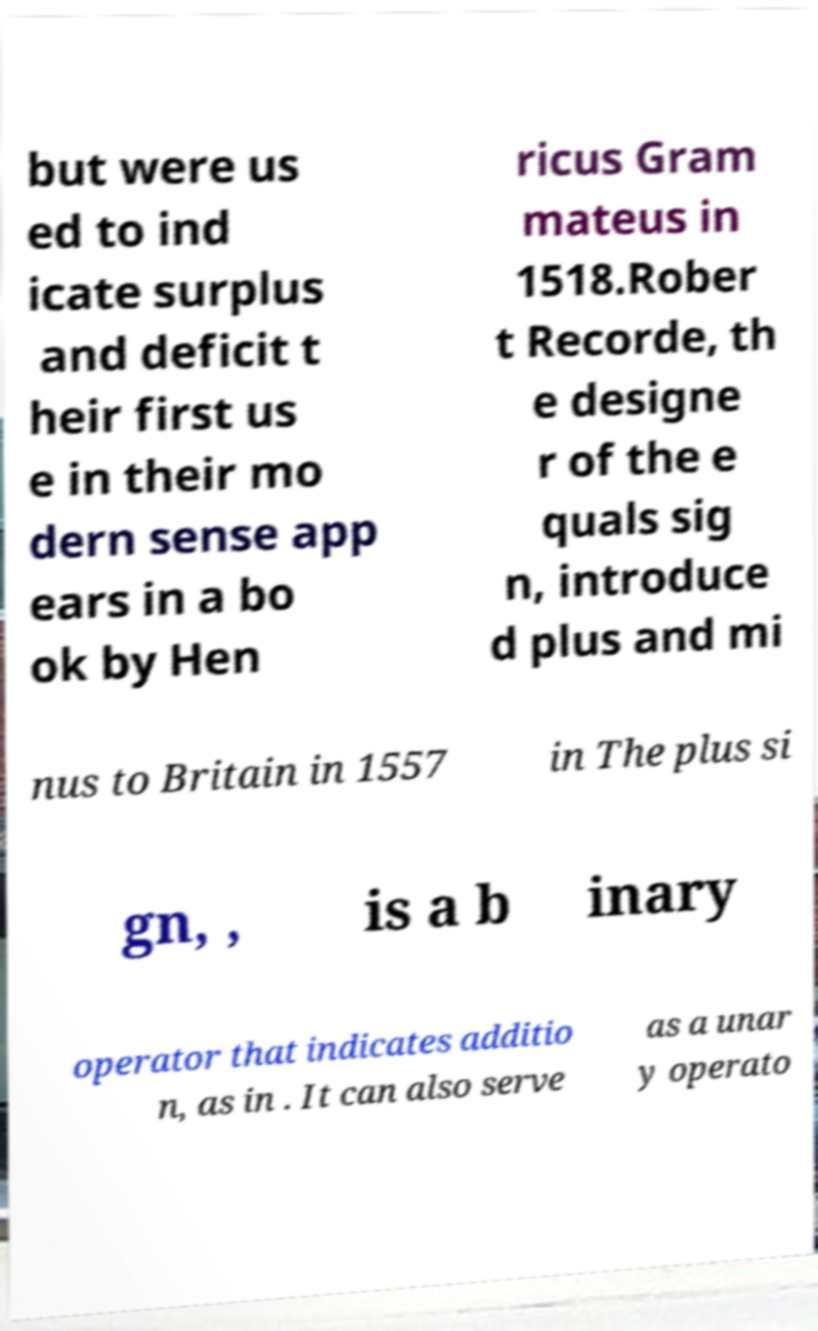I need the written content from this picture converted into text. Can you do that? but were us ed to ind icate surplus and deficit t heir first us e in their mo dern sense app ears in a bo ok by Hen ricus Gram mateus in 1518.Rober t Recorde, th e designe r of the e quals sig n, introduce d plus and mi nus to Britain in 1557 in The plus si gn, , is a b inary operator that indicates additio n, as in . It can also serve as a unar y operato 